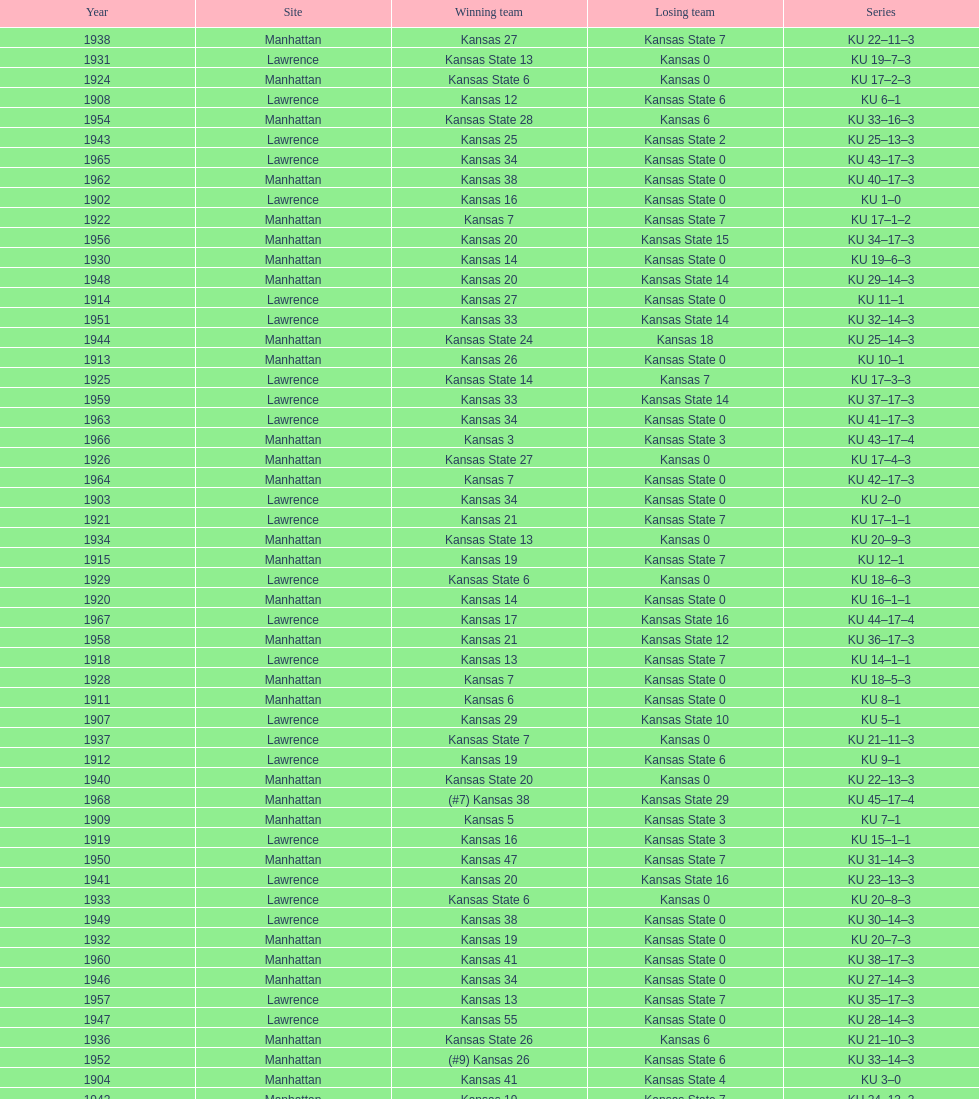Who had the most wins in the 1950's: kansas or kansas state? Kansas. Would you mind parsing the complete table? {'header': ['Year', 'Site', 'Winning team', 'Losing team', 'Series'], 'rows': [['1938', 'Manhattan', 'Kansas 27', 'Kansas State 7', 'KU 22–11–3'], ['1931', 'Lawrence', 'Kansas State 13', 'Kansas 0', 'KU 19–7–3'], ['1924', 'Manhattan', 'Kansas State 6', 'Kansas 0', 'KU 17–2–3'], ['1908', 'Lawrence', 'Kansas 12', 'Kansas State 6', 'KU 6–1'], ['1954', 'Manhattan', 'Kansas State 28', 'Kansas 6', 'KU 33–16–3'], ['1943', 'Lawrence', 'Kansas 25', 'Kansas State 2', 'KU 25–13–3'], ['1965', 'Lawrence', 'Kansas 34', 'Kansas State 0', 'KU 43–17–3'], ['1962', 'Manhattan', 'Kansas 38', 'Kansas State 0', 'KU 40–17–3'], ['1902', 'Lawrence', 'Kansas 16', 'Kansas State 0', 'KU 1–0'], ['1922', 'Manhattan', 'Kansas 7', 'Kansas State 7', 'KU 17–1–2'], ['1956', 'Manhattan', 'Kansas 20', 'Kansas State 15', 'KU 34–17–3'], ['1930', 'Manhattan', 'Kansas 14', 'Kansas State 0', 'KU 19–6–3'], ['1948', 'Manhattan', 'Kansas 20', 'Kansas State 14', 'KU 29–14–3'], ['1914', 'Lawrence', 'Kansas 27', 'Kansas State 0', 'KU 11–1'], ['1951', 'Lawrence', 'Kansas 33', 'Kansas State 14', 'KU 32–14–3'], ['1944', 'Manhattan', 'Kansas State 24', 'Kansas 18', 'KU 25–14–3'], ['1913', 'Manhattan', 'Kansas 26', 'Kansas State 0', 'KU 10–1'], ['1925', 'Lawrence', 'Kansas State 14', 'Kansas 7', 'KU 17–3–3'], ['1959', 'Lawrence', 'Kansas 33', 'Kansas State 14', 'KU 37–17–3'], ['1963', 'Lawrence', 'Kansas 34', 'Kansas State 0', 'KU 41–17–3'], ['1966', 'Manhattan', 'Kansas 3', 'Kansas State 3', 'KU 43–17–4'], ['1926', 'Manhattan', 'Kansas State 27', 'Kansas 0', 'KU 17–4–3'], ['1964', 'Manhattan', 'Kansas 7', 'Kansas State 0', 'KU 42–17–3'], ['1903', 'Lawrence', 'Kansas 34', 'Kansas State 0', 'KU 2–0'], ['1921', 'Lawrence', 'Kansas 21', 'Kansas State 7', 'KU 17–1–1'], ['1934', 'Manhattan', 'Kansas State 13', 'Kansas 0', 'KU 20–9–3'], ['1915', 'Manhattan', 'Kansas 19', 'Kansas State 7', 'KU 12–1'], ['1929', 'Lawrence', 'Kansas State 6', 'Kansas 0', 'KU 18–6–3'], ['1920', 'Manhattan', 'Kansas 14', 'Kansas State 0', 'KU 16–1–1'], ['1967', 'Lawrence', 'Kansas 17', 'Kansas State 16', 'KU 44–17–4'], ['1958', 'Manhattan', 'Kansas 21', 'Kansas State 12', 'KU 36–17–3'], ['1918', 'Lawrence', 'Kansas 13', 'Kansas State 7', 'KU 14–1–1'], ['1928', 'Manhattan', 'Kansas 7', 'Kansas State 0', 'KU 18–5–3'], ['1911', 'Manhattan', 'Kansas 6', 'Kansas State 0', 'KU 8–1'], ['1907', 'Lawrence', 'Kansas 29', 'Kansas State 10', 'KU 5–1'], ['1937', 'Lawrence', 'Kansas State 7', 'Kansas 0', 'KU 21–11–3'], ['1912', 'Lawrence', 'Kansas 19', 'Kansas State 6', 'KU 9–1'], ['1940', 'Manhattan', 'Kansas State 20', 'Kansas 0', 'KU 22–13–3'], ['1968', 'Manhattan', '(#7) Kansas 38', 'Kansas State 29', 'KU 45–17–4'], ['1909', 'Manhattan', 'Kansas 5', 'Kansas State 3', 'KU 7–1'], ['1919', 'Lawrence', 'Kansas 16', 'Kansas State 3', 'KU 15–1–1'], ['1950', 'Manhattan', 'Kansas 47', 'Kansas State 7', 'KU 31–14–3'], ['1941', 'Lawrence', 'Kansas 20', 'Kansas State 16', 'KU 23–13–3'], ['1933', 'Lawrence', 'Kansas State 6', 'Kansas 0', 'KU 20–8–3'], ['1949', 'Lawrence', 'Kansas 38', 'Kansas State 0', 'KU 30–14–3'], ['1932', 'Manhattan', 'Kansas 19', 'Kansas State 0', 'KU 20–7–3'], ['1960', 'Manhattan', 'Kansas 41', 'Kansas State 0', 'KU 38–17–3'], ['1946', 'Manhattan', 'Kansas 34', 'Kansas State 0', 'KU 27–14–3'], ['1957', 'Lawrence', 'Kansas 13', 'Kansas State 7', 'KU 35–17–3'], ['1947', 'Lawrence', 'Kansas 55', 'Kansas State 0', 'KU 28–14–3'], ['1936', 'Manhattan', 'Kansas State 26', 'Kansas 6', 'KU 21–10–3'], ['1952', 'Manhattan', '(#9) Kansas 26', 'Kansas State 6', 'KU 33–14–3'], ['1904', 'Manhattan', 'Kansas 41', 'Kansas State 4', 'KU 3–0'], ['1942', 'Manhattan', 'Kansas 19', 'Kansas State 7', 'KU 24–13–3'], ['1955', 'Lawrence', 'Kansas State 46', 'Kansas 0', 'KU 33–17–3'], ['1961', 'Lawrence', 'Kansas 34', 'Kansas State 0', 'KU 39–17–3'], ['1923', 'Lawrence', 'Kansas 0', 'Kansas State 0', 'KU 17–1–3'], ['1927', 'Lawrence', 'Kansas State 13', 'Kansas 2', 'KU 17–5–3'], ['1905', 'Lawrence', 'Kansas 28', 'Kansas State 0', 'KU 4–0'], ['1916', 'Lawrence', 'Kansas 0', 'Kansas State 0', 'KU 12–1–1'], ['1935', 'Lawrence', 'Kansas 9', 'Kansas State 2', 'KU 21–9–3'], ['1953', 'Lawrence', 'Kansas State 7', 'Kansas 0', 'KU 33–15–3'], ['1945', 'Lawrence', 'Kansas 27', 'Kansas State 0', 'KU 26–14–3'], ['1939', 'Lawrence', 'Kansas State 27', 'Kansas 6', 'KU 22–12–3'], ['1917', 'Manhattan', 'Kansas 9', 'Kansas State 0', 'KU 13–1–1'], ['1906', 'Manhattan', 'Kansas State 6', 'Kansas 4', 'KU 4–1']]} 